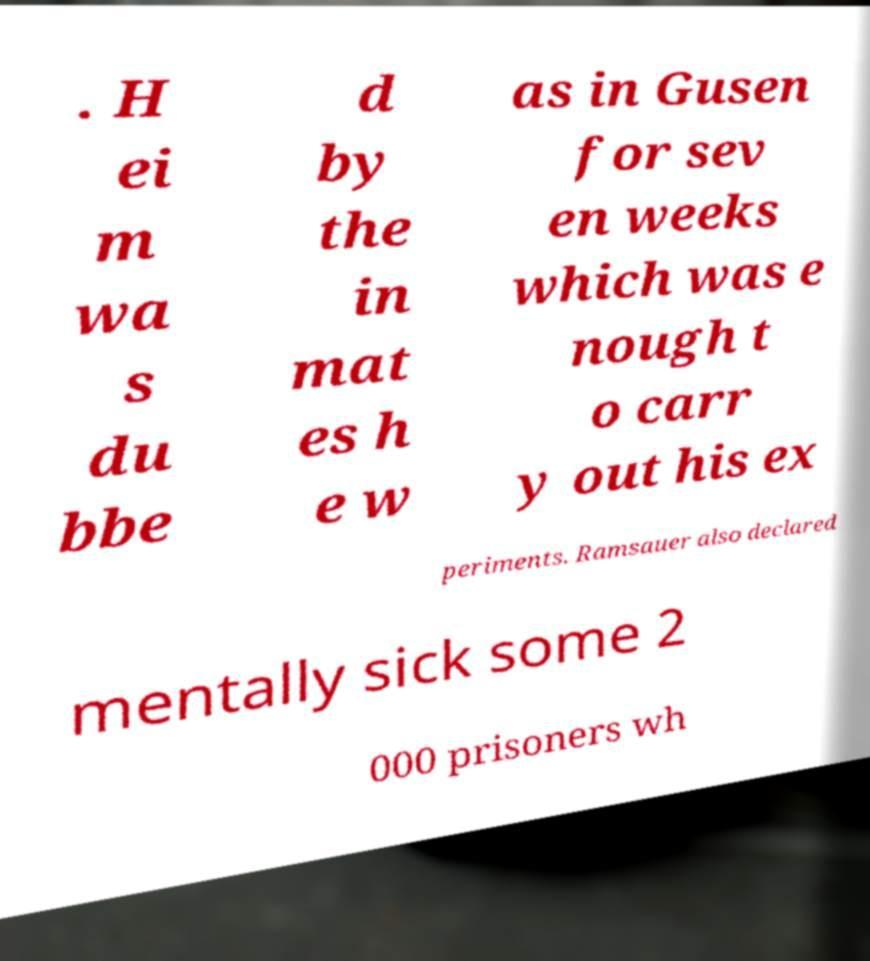For documentation purposes, I need the text within this image transcribed. Could you provide that? . H ei m wa s du bbe d by the in mat es h e w as in Gusen for sev en weeks which was e nough t o carr y out his ex periments. Ramsauer also declared mentally sick some 2 000 prisoners wh 